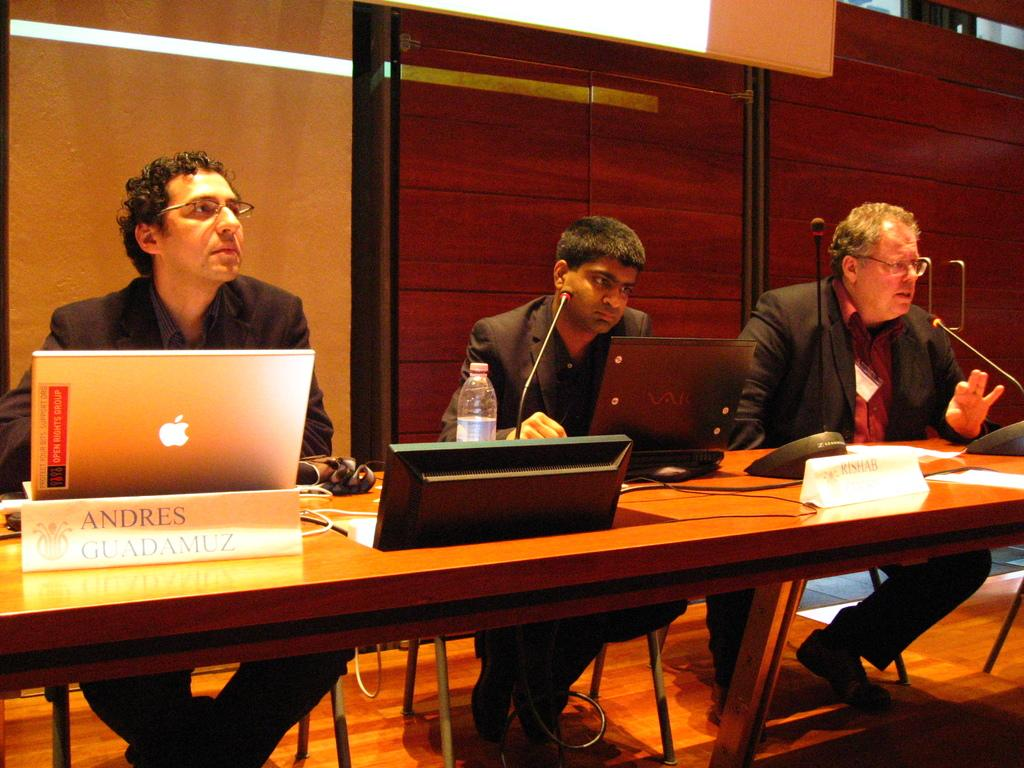How many people are present in the image? There are three people in the image. What object can be seen on a table in the image? There is a laptop on a table in the image. Are there any other items on the table besides the laptop? Yes, there is a bottle on the table in the image. What type of throat lozenges can be seen in the image? There are no throat lozenges present in the image. Is there a church visible in the background of the image? There is no mention of a church or any background in the provided facts, so it cannot be determined from the image. 